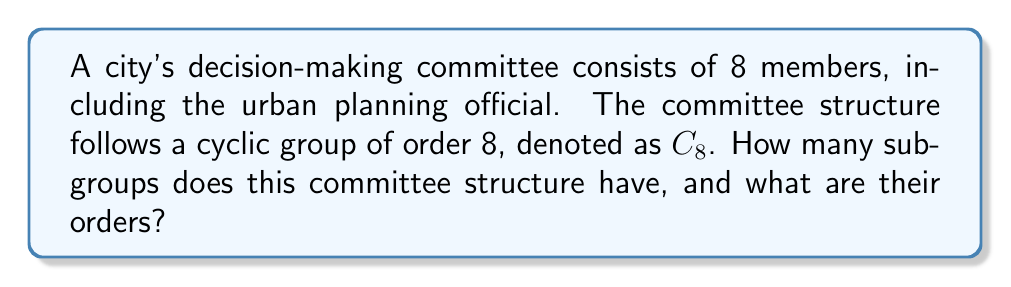Could you help me with this problem? To solve this problem, we need to understand the properties of cyclic groups and their subgroups:

1) A cyclic group of order $n$, denoted as $C_n$, has subgroups for each divisor of $n$.

2) The order of each subgroup is equal to the corresponding divisor.

3) There is exactly one subgroup for each divisor of $n$.

Let's approach this step-by-step:

1) First, we need to find the divisors of 8:
   The divisors of 8 are 1, 2, 4, and 8.

2) Now, we can determine the subgroups:
   - There is one subgroup of order 1 (the trivial subgroup)
   - There is one subgroup of order 2
   - There is one subgroup of order 4
   - There is one subgroup of order 8 (the entire group)

3) To count the total number of subgroups, we simply add these up:
   1 + 1 + 1 + 1 = 4

Therefore, the cyclic group $C_8$ has 4 subgroups in total.

In the context of the urban planning committee, this means:
- The full committee of 8 members can make decisions as a whole.
- There are also subcommittees of 4 members and 2 members that can make certain decisions.
- The trivial subgroup (1 member) represents individual decision-making power, which might be relevant for certain minor decisions or emergency situations.

This structure allows for flexible decision-making at various levels, supporting the urban planning official's belief in collaborative and empowered community decision-making.
Answer: The committee structure, modeled as $C_8$, has 4 subgroups with orders 1, 2, 4, and 8. 